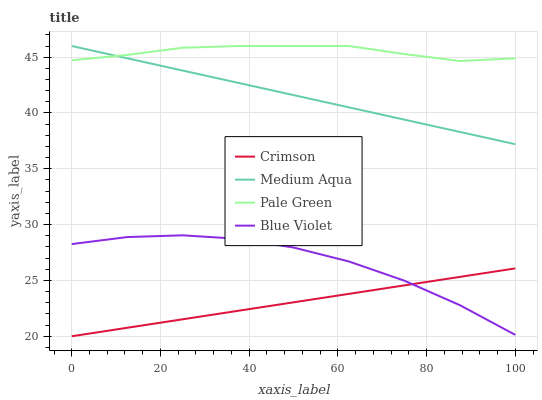Does Crimson have the minimum area under the curve?
Answer yes or no. Yes. Does Pale Green have the maximum area under the curve?
Answer yes or no. Yes. Does Medium Aqua have the minimum area under the curve?
Answer yes or no. No. Does Medium Aqua have the maximum area under the curve?
Answer yes or no. No. Is Crimson the smoothest?
Answer yes or no. Yes. Is Blue Violet the roughest?
Answer yes or no. Yes. Is Pale Green the smoothest?
Answer yes or no. No. Is Pale Green the roughest?
Answer yes or no. No. Does Crimson have the lowest value?
Answer yes or no. Yes. Does Medium Aqua have the lowest value?
Answer yes or no. No. Does Medium Aqua have the highest value?
Answer yes or no. Yes. Does Blue Violet have the highest value?
Answer yes or no. No. Is Crimson less than Medium Aqua?
Answer yes or no. Yes. Is Medium Aqua greater than Blue Violet?
Answer yes or no. Yes. Does Medium Aqua intersect Pale Green?
Answer yes or no. Yes. Is Medium Aqua less than Pale Green?
Answer yes or no. No. Is Medium Aqua greater than Pale Green?
Answer yes or no. No. Does Crimson intersect Medium Aqua?
Answer yes or no. No. 